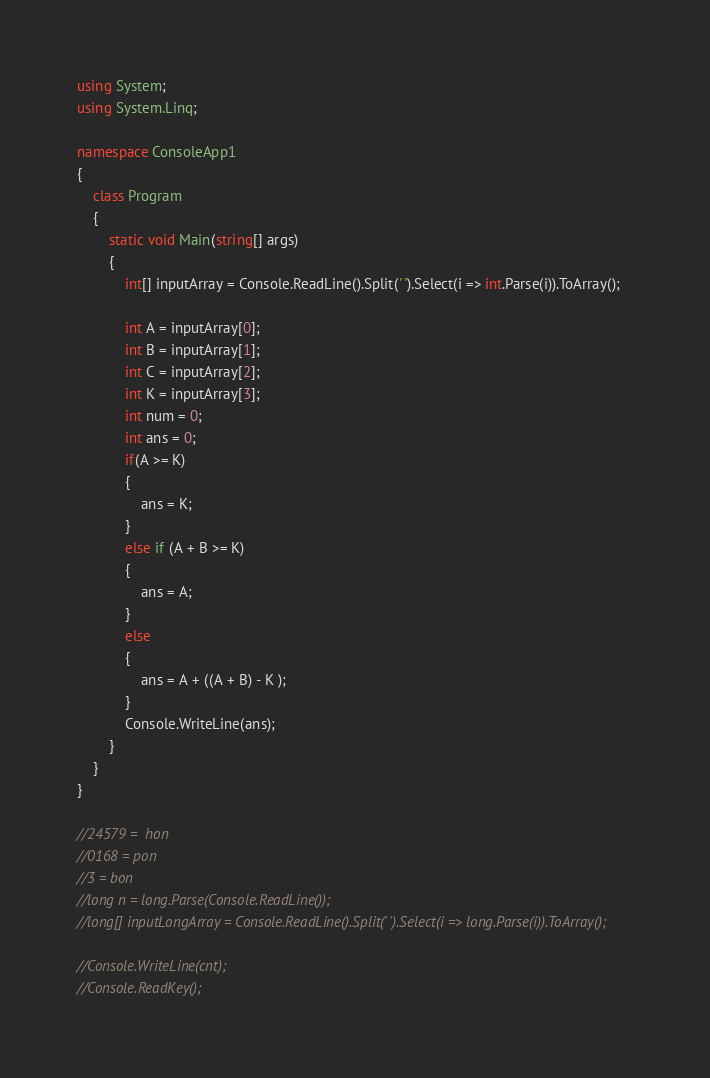Convert code to text. <code><loc_0><loc_0><loc_500><loc_500><_C#_>using System;
using System.Linq;

namespace ConsoleApp1
{
    class Program
    {
        static void Main(string[] args)
        {
            int[] inputArray = Console.ReadLine().Split(' ').Select(i => int.Parse(i)).ToArray();

            int A = inputArray[0];
            int B = inputArray[1];
            int C = inputArray[2];
            int K = inputArray[3];
            int num = 0;
            int ans = 0;
            if(A >= K)
            {
                ans = K;
            }
            else if (A + B >= K)
            {
                ans = A;
            }
            else
            {
                ans = A + ((A + B) - K );
            }
            Console.WriteLine(ans);
        }
    }
}

//24579 =  hon
//0168 = pon
//3 = bon
//long n = long.Parse(Console.ReadLine());
//long[] inputLongArray = Console.ReadLine().Split(' ').Select(i => long.Parse(i)).ToArray();

//Console.WriteLine(cnt);
//Console.ReadKey();
</code> 